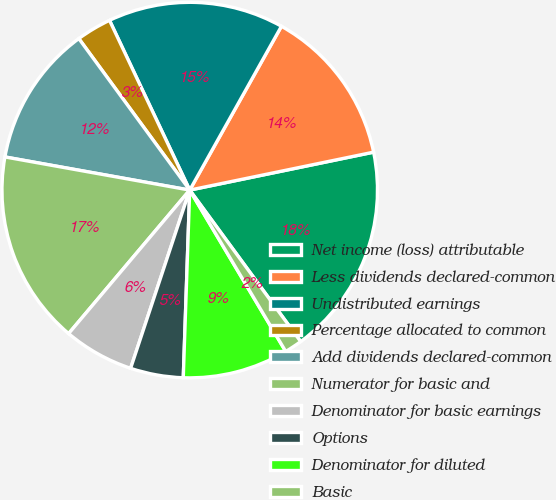Convert chart to OTSL. <chart><loc_0><loc_0><loc_500><loc_500><pie_chart><fcel>Net income (loss) attributable<fcel>Less dividends declared-common<fcel>Undistributed earnings<fcel>Percentage allocated to common<fcel>Add dividends declared-common<fcel>Numerator for basic and<fcel>Denominator for basic earnings<fcel>Options<fcel>Denominator for diluted<fcel>Basic<nl><fcel>18.18%<fcel>13.64%<fcel>15.15%<fcel>3.03%<fcel>12.12%<fcel>16.67%<fcel>6.06%<fcel>4.55%<fcel>9.09%<fcel>1.52%<nl></chart> 